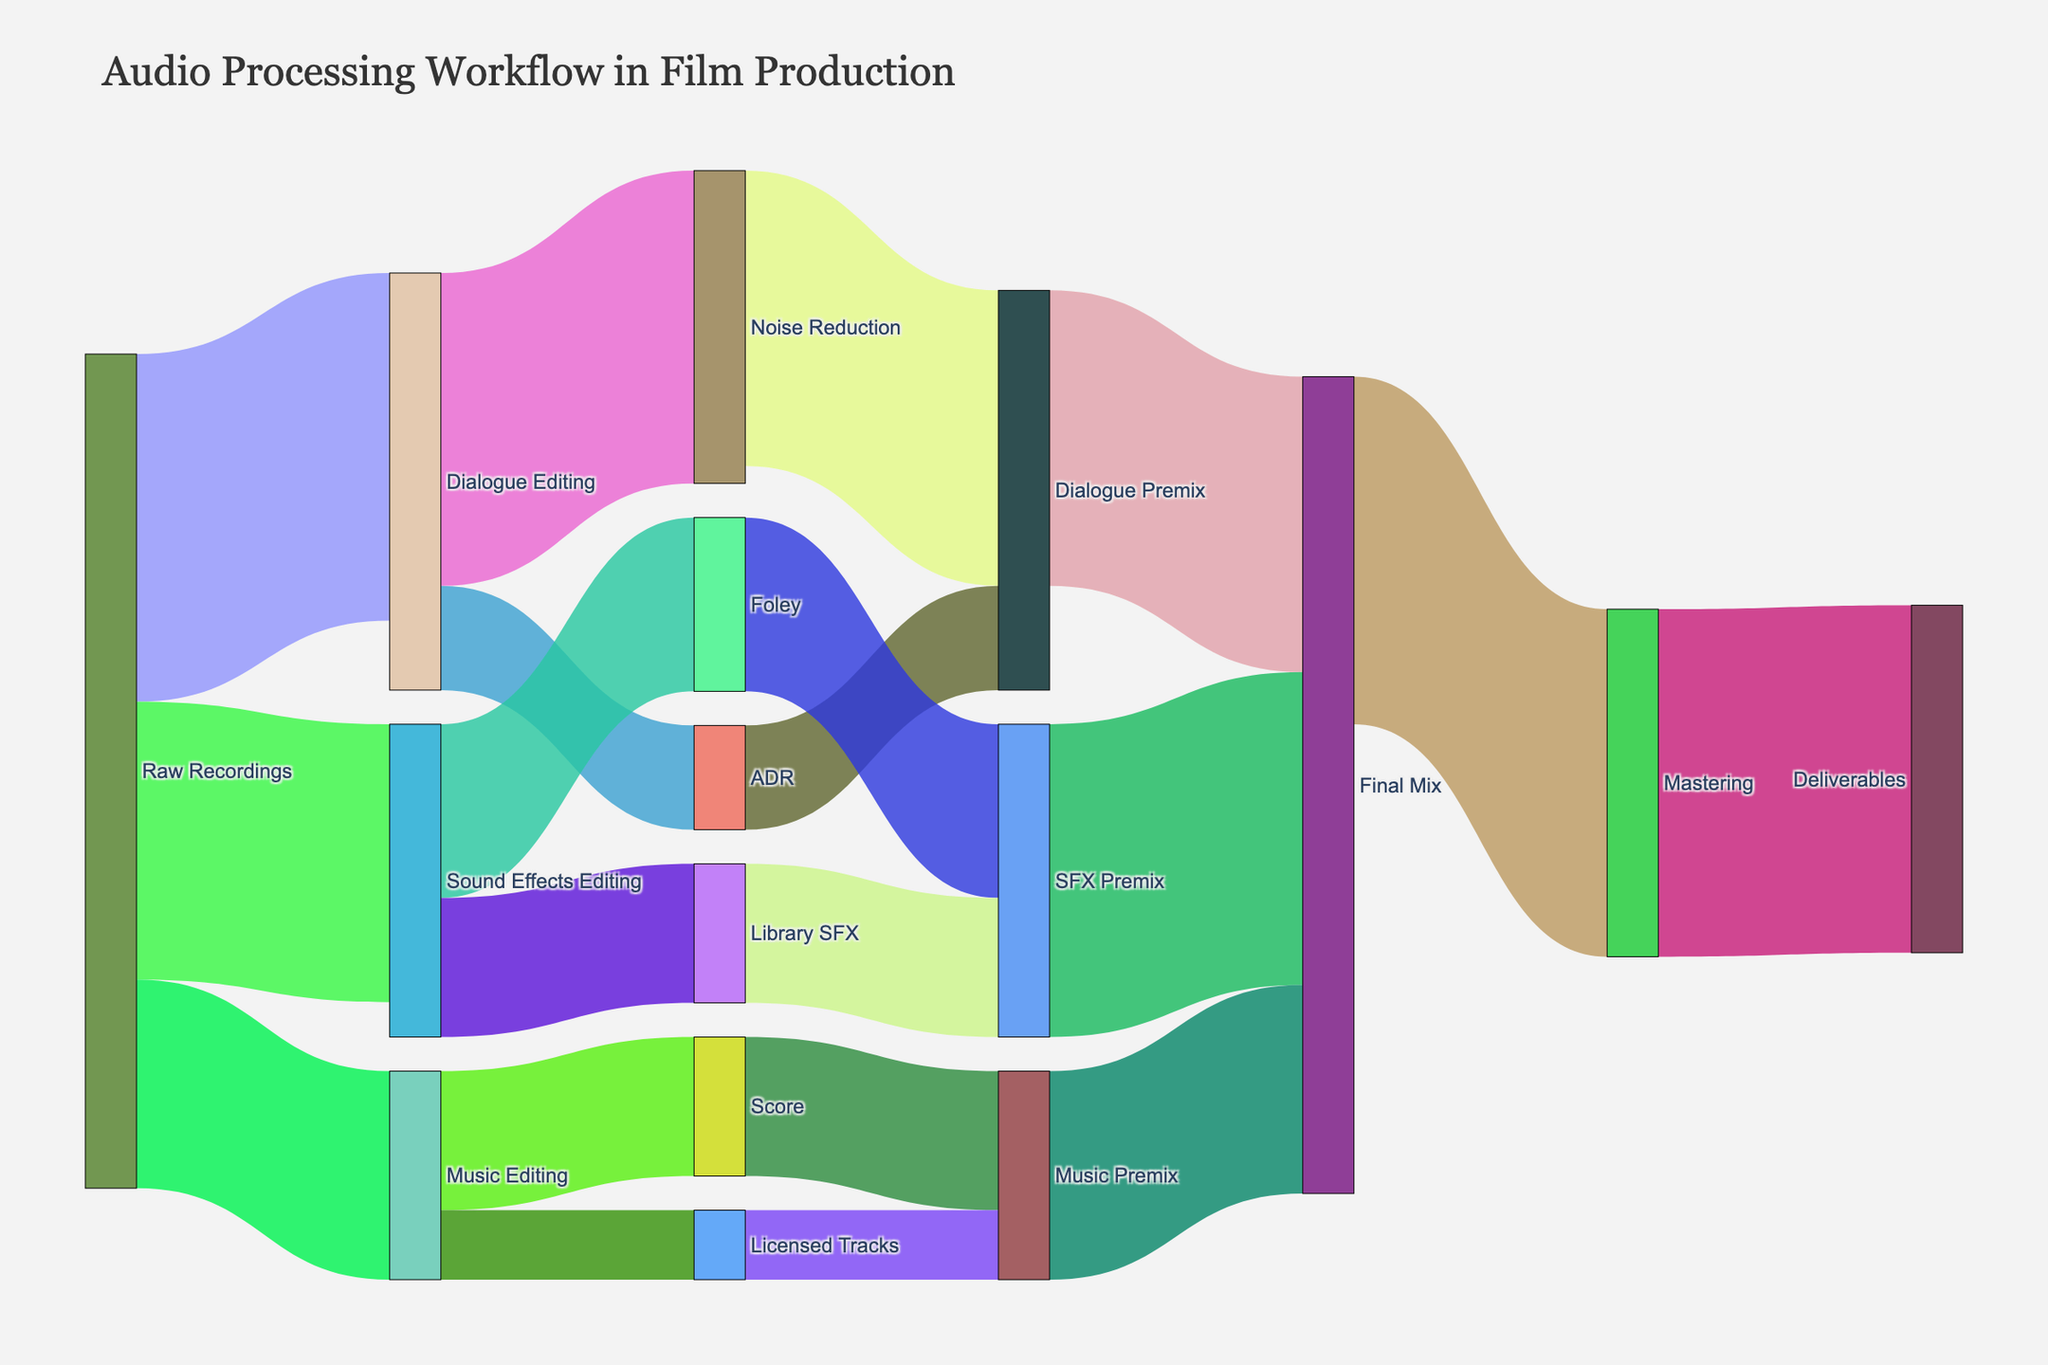What's the title of the figure? The title is displayed at the top of the Sankey Diagram. It provides a quick summary of what the diagram depicts.
Answer: Audio Processing Workflow in Film Production How many steps are involved from Raw Recordings to the Final Mix? Following the paths from Raw Recordings, they lead to Dialogue Editing, Sound Effects Editing, and Music Editing. Each of these branches further splits, but crucially, they all converge again at the Final Mix through intermediary steps. Counting these steps: 1. Raw Recordings, 2. Dialogue/Sound Effects/Music Editing, 3. Noise Reduction/ADR/Foley/Library SFX/Score/Licensed Tracks, 4. Dialogue/SFX/Music Premix, 5. Final Mix.
Answer: 5 Which stage has the highest value flow, and what is the value? The value can be identified by looking at the link with the highest thickness in the Sankey Diagram. The value indicates the amount of whatever quantity (in this case, possibly hours or effort) being processed. The highest value flow is from Raw Recordings to Dialogue Editing.
Answer: Dialogue Editing, 100 Compare the values between Foley and Library SFX. Which one has a greater value and by how much? Identifying the values associated with Foley and Library SFX by examining their respective flow thicknesses, we see that Foley is 50 and Library SFX is 40. Calculating the difference: 50 - 40.
Answer: Foley, by 10 From Dialogue Premix, what are the next steps, and what are their values? By following the arrows from Dialogue Premix to its targets, we observe that it flows into Final Mix with a value of 85.
Answer: Final Mix, 85 Which intermediary stage leads directly to both Final Mix and Mastering? Tracing the flow that leads to both Final Mix and Mastering by considering the node connections, we find that Final Mix flows into Mastering. The intermediary stage connecting to both is Final Mix.
Answer: Final Mix What are the total values flowing into the Final Mix from all sources? Identifying all paths flowing into the Final Mix, the values are 85 from Dialogue Premix, 90 from SFX Premix, and 60 from Music Premix. Summing these up: 85 + 90 + 60.
Answer: 235 What is the proportion of Music Premix going to the Final Mix compared to the total input values of the Final Mix? Calculating the proportion by dividing the Music Premix value (60) by the total input values of Final Mix (235): (60/235) * 100.
Answer: ~25.5% After Noise Reduction, what are the possible next paths and their total values? Following the paths from Noise Reduction leads to Dialogue Premix with a value of 85. This is the only next step.
Answer: Dialogue Premix, 85 Which editing phase receives the least amount of input and what is its value? Identifying the input values for Dialogue Editing, Sound Effects Editing, and Music Editing, we find Music Editing receives the least input from Raw Recordings at 60.
Answer: Music Editing, 60 